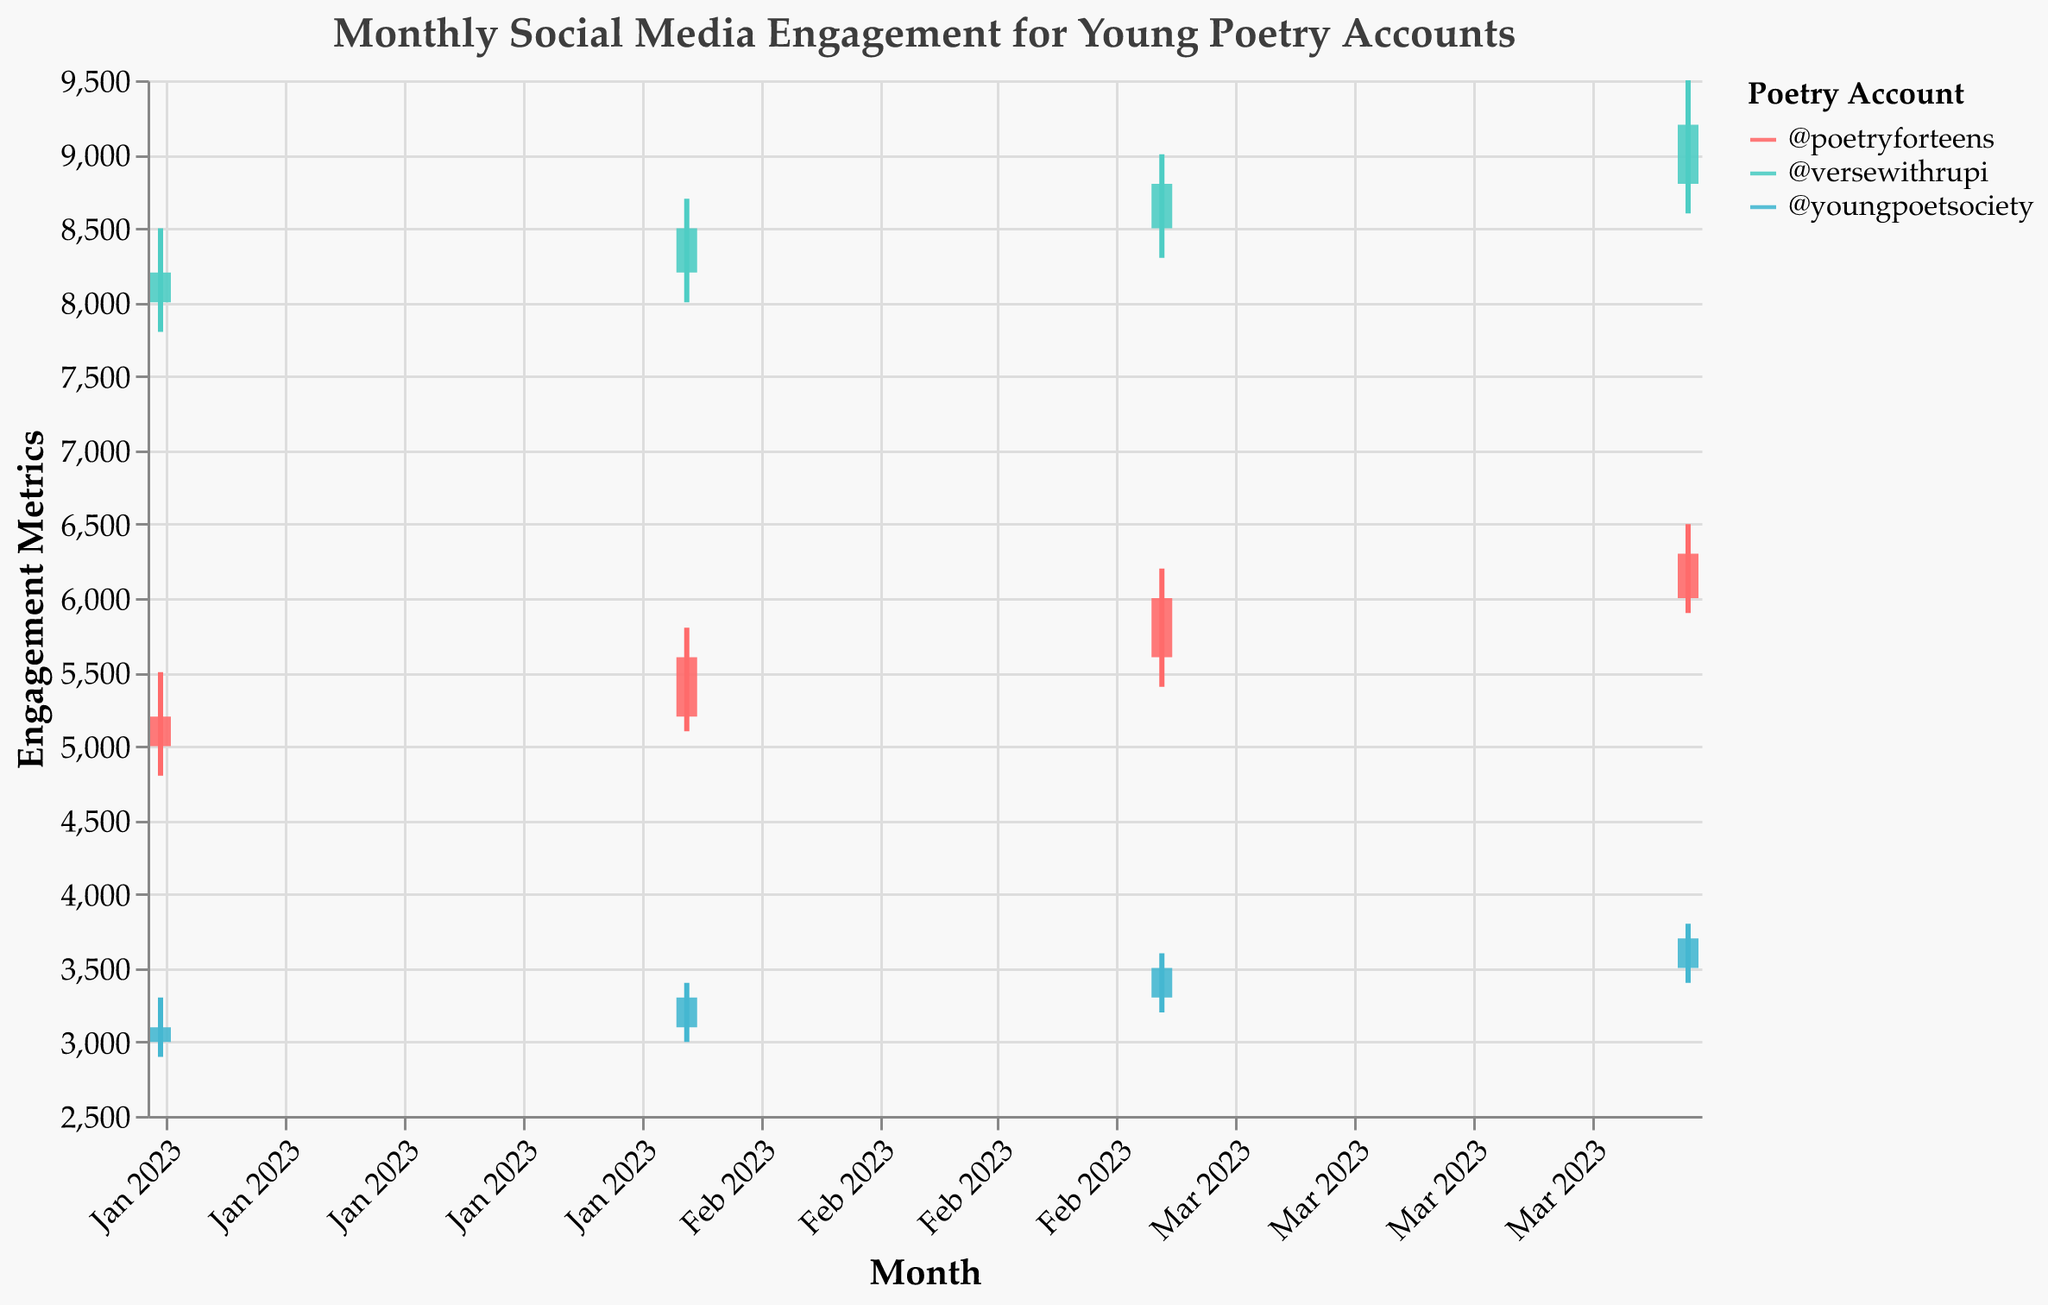What trend can be observed in @poetryforteens' engagement metrics from January to April? @poetryforteens shows a consistent increase in engagement metrics each month, with opening values rising from 5000 in January to 6000 in April, and closing values increasing from 5200 in January to 6300 in April.
Answer: Consistent increase Which account had the highest engagement in April? In April, @versewithrupi had the highest engagement with a high value of 9500 and a closing value of 9200, higher than the other two accounts.
Answer: @versewithrupi How does @youngpoetsociety's engagement compare between February and March? In February, @youngpoetsociety's engagement metrics were 3100 (open) and 3300 (close). In March, these increased to 3300 (open) and 3500 (close). Hence, there is an increase in both opening and closing values from February to March.
Answer: Increased What is the average closing value for @versewithrupi from January to April? The closing values for @versewithrupi from January to April are 8200, 8500, 8800, and 9200. The average closing value can be calculated as (8200 + 8500 + 8800 + 9200) / 4 = 36700 / 4 = 9175.
Answer: 9175 Did any account's engagement metrics decline from March to April? All accounts (@poetryforteens, @versewithrupi, @youngpoetsociety) show an increase in their engagement metrics from March to April, without any declines.
Answer: No Which account had the smallest range (difference between high and low) in March? For March, @poetryforteens has a range of 6200 - 5400 = 800, @versewithrupi has a range of 9000 - 8300 = 700, and @youngpoetsociety has a range of 3600 - 3200 = 400. @youngpoetsociety has the smallest range of 400.
Answer: @youngpoetsociety What can be inferred about the stability of engagement for @versewithrupi through the given months? @versewithrupi has exhibited a steady, relatively high engagement metric with consistent increases in both high and close values each month, indicating stable and growing engagement.
Answer: Stable and growing How does the engagement movement of @youngpoetsociety in February differ from its movement in April? In February, @youngpoetsociety opened at 3100 and closed at 3300, a positive change. In April, it opened at 3500 and closed at 3700, maintaining a similar positive change showing growth in both periods.
Answer: Positive movement in both months 